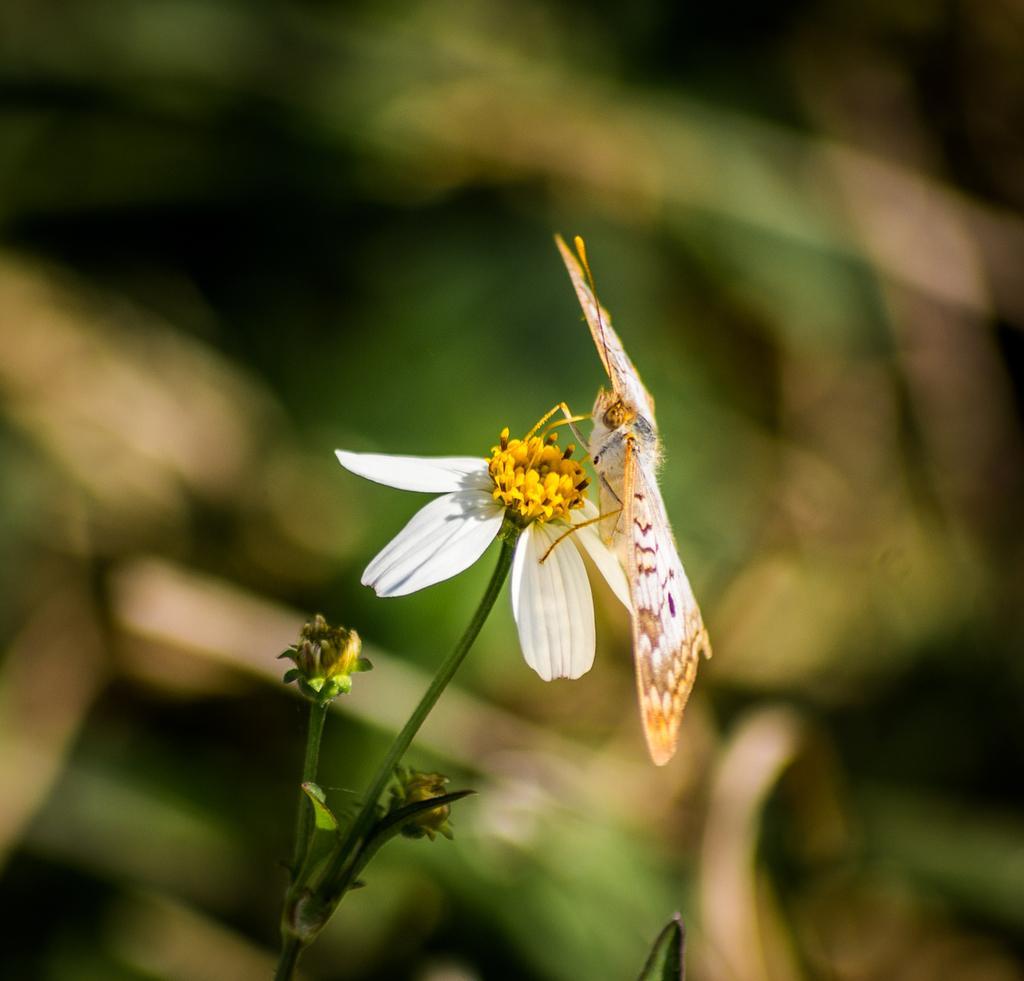Describe this image in one or two sentences. In this image there is a butterfly on the flower and the background of the image is blur. 